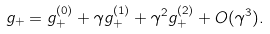<formula> <loc_0><loc_0><loc_500><loc_500>g _ { + } = g ^ { ( 0 ) } _ { + } + \gamma g ^ { ( 1 ) } _ { + } + \gamma ^ { 2 } g ^ { ( 2 ) } _ { + } + O ( \gamma ^ { 3 } ) .</formula> 